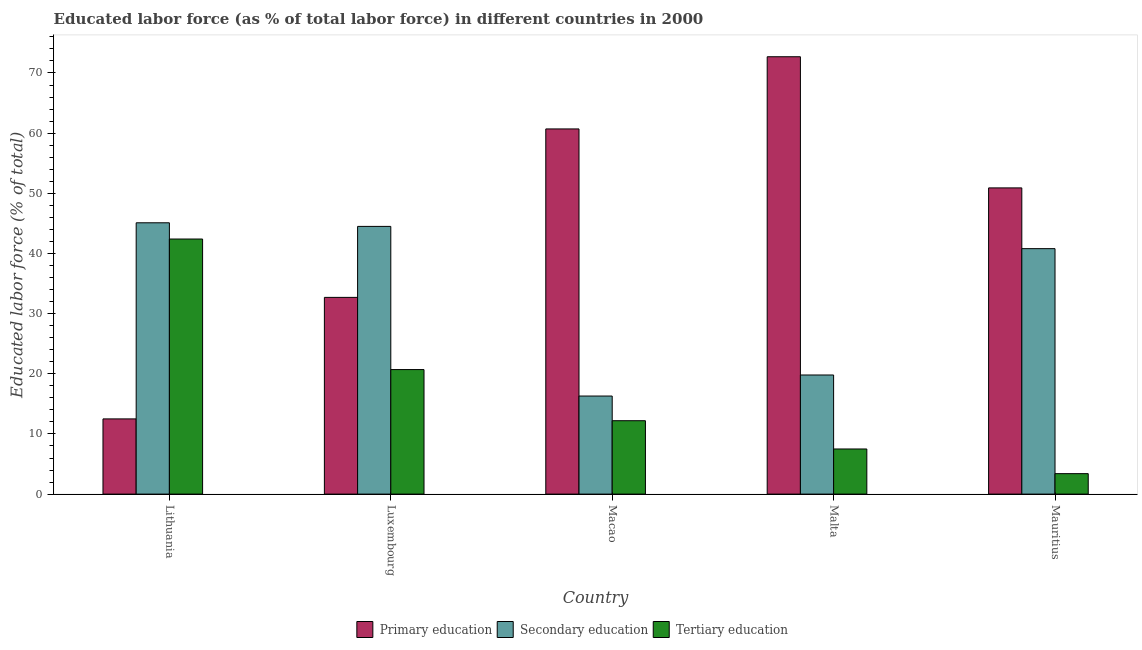How many different coloured bars are there?
Offer a terse response. 3. How many bars are there on the 5th tick from the left?
Provide a succinct answer. 3. What is the label of the 3rd group of bars from the left?
Your response must be concise. Macao. In how many cases, is the number of bars for a given country not equal to the number of legend labels?
Provide a succinct answer. 0. What is the percentage of labor force who received tertiary education in Luxembourg?
Your response must be concise. 20.7. Across all countries, what is the maximum percentage of labor force who received primary education?
Your answer should be compact. 72.7. Across all countries, what is the minimum percentage of labor force who received tertiary education?
Your answer should be compact. 3.4. In which country was the percentage of labor force who received secondary education maximum?
Offer a terse response. Lithuania. In which country was the percentage of labor force who received primary education minimum?
Keep it short and to the point. Lithuania. What is the total percentage of labor force who received tertiary education in the graph?
Provide a short and direct response. 86.2. What is the difference between the percentage of labor force who received tertiary education in Malta and that in Mauritius?
Give a very brief answer. 4.1. What is the difference between the percentage of labor force who received secondary education in Macao and the percentage of labor force who received primary education in Mauritius?
Give a very brief answer. -34.6. What is the average percentage of labor force who received primary education per country?
Ensure brevity in your answer.  45.9. What is the difference between the percentage of labor force who received secondary education and percentage of labor force who received tertiary education in Mauritius?
Provide a short and direct response. 37.4. In how many countries, is the percentage of labor force who received secondary education greater than 72 %?
Your answer should be compact. 0. What is the ratio of the percentage of labor force who received secondary education in Lithuania to that in Malta?
Provide a short and direct response. 2.28. Is the percentage of labor force who received primary education in Luxembourg less than that in Mauritius?
Your response must be concise. Yes. Is the difference between the percentage of labor force who received secondary education in Macao and Mauritius greater than the difference between the percentage of labor force who received tertiary education in Macao and Mauritius?
Provide a short and direct response. No. What is the difference between the highest and the second highest percentage of labor force who received tertiary education?
Provide a succinct answer. 21.7. What is the difference between the highest and the lowest percentage of labor force who received secondary education?
Make the answer very short. 28.8. In how many countries, is the percentage of labor force who received primary education greater than the average percentage of labor force who received primary education taken over all countries?
Provide a succinct answer. 3. What does the 1st bar from the left in Lithuania represents?
Keep it short and to the point. Primary education. How many bars are there?
Offer a terse response. 15. How many countries are there in the graph?
Your answer should be very brief. 5. What is the difference between two consecutive major ticks on the Y-axis?
Offer a terse response. 10. Are the values on the major ticks of Y-axis written in scientific E-notation?
Offer a terse response. No. Where does the legend appear in the graph?
Your answer should be very brief. Bottom center. How many legend labels are there?
Your answer should be very brief. 3. What is the title of the graph?
Offer a very short reply. Educated labor force (as % of total labor force) in different countries in 2000. Does "Coal" appear as one of the legend labels in the graph?
Offer a terse response. No. What is the label or title of the Y-axis?
Make the answer very short. Educated labor force (% of total). What is the Educated labor force (% of total) of Secondary education in Lithuania?
Provide a succinct answer. 45.1. What is the Educated labor force (% of total) of Tertiary education in Lithuania?
Your answer should be very brief. 42.4. What is the Educated labor force (% of total) in Primary education in Luxembourg?
Keep it short and to the point. 32.7. What is the Educated labor force (% of total) in Secondary education in Luxembourg?
Give a very brief answer. 44.5. What is the Educated labor force (% of total) in Tertiary education in Luxembourg?
Offer a very short reply. 20.7. What is the Educated labor force (% of total) in Primary education in Macao?
Your answer should be very brief. 60.7. What is the Educated labor force (% of total) of Secondary education in Macao?
Give a very brief answer. 16.3. What is the Educated labor force (% of total) in Tertiary education in Macao?
Make the answer very short. 12.2. What is the Educated labor force (% of total) in Primary education in Malta?
Make the answer very short. 72.7. What is the Educated labor force (% of total) in Secondary education in Malta?
Make the answer very short. 19.8. What is the Educated labor force (% of total) of Tertiary education in Malta?
Your answer should be very brief. 7.5. What is the Educated labor force (% of total) in Primary education in Mauritius?
Give a very brief answer. 50.9. What is the Educated labor force (% of total) of Secondary education in Mauritius?
Your answer should be very brief. 40.8. What is the Educated labor force (% of total) in Tertiary education in Mauritius?
Your response must be concise. 3.4. Across all countries, what is the maximum Educated labor force (% of total) in Primary education?
Offer a very short reply. 72.7. Across all countries, what is the maximum Educated labor force (% of total) of Secondary education?
Give a very brief answer. 45.1. Across all countries, what is the maximum Educated labor force (% of total) in Tertiary education?
Provide a succinct answer. 42.4. Across all countries, what is the minimum Educated labor force (% of total) in Primary education?
Ensure brevity in your answer.  12.5. Across all countries, what is the minimum Educated labor force (% of total) of Secondary education?
Provide a succinct answer. 16.3. Across all countries, what is the minimum Educated labor force (% of total) in Tertiary education?
Offer a very short reply. 3.4. What is the total Educated labor force (% of total) of Primary education in the graph?
Give a very brief answer. 229.5. What is the total Educated labor force (% of total) of Secondary education in the graph?
Offer a very short reply. 166.5. What is the total Educated labor force (% of total) of Tertiary education in the graph?
Offer a very short reply. 86.2. What is the difference between the Educated labor force (% of total) in Primary education in Lithuania and that in Luxembourg?
Keep it short and to the point. -20.2. What is the difference between the Educated labor force (% of total) of Secondary education in Lithuania and that in Luxembourg?
Keep it short and to the point. 0.6. What is the difference between the Educated labor force (% of total) in Tertiary education in Lithuania and that in Luxembourg?
Offer a very short reply. 21.7. What is the difference between the Educated labor force (% of total) in Primary education in Lithuania and that in Macao?
Offer a terse response. -48.2. What is the difference between the Educated labor force (% of total) in Secondary education in Lithuania and that in Macao?
Make the answer very short. 28.8. What is the difference between the Educated labor force (% of total) of Tertiary education in Lithuania and that in Macao?
Your response must be concise. 30.2. What is the difference between the Educated labor force (% of total) of Primary education in Lithuania and that in Malta?
Provide a succinct answer. -60.2. What is the difference between the Educated labor force (% of total) in Secondary education in Lithuania and that in Malta?
Provide a succinct answer. 25.3. What is the difference between the Educated labor force (% of total) of Tertiary education in Lithuania and that in Malta?
Your answer should be very brief. 34.9. What is the difference between the Educated labor force (% of total) in Primary education in Lithuania and that in Mauritius?
Make the answer very short. -38.4. What is the difference between the Educated labor force (% of total) in Secondary education in Lithuania and that in Mauritius?
Provide a succinct answer. 4.3. What is the difference between the Educated labor force (% of total) of Secondary education in Luxembourg and that in Macao?
Ensure brevity in your answer.  28.2. What is the difference between the Educated labor force (% of total) in Primary education in Luxembourg and that in Malta?
Ensure brevity in your answer.  -40. What is the difference between the Educated labor force (% of total) of Secondary education in Luxembourg and that in Malta?
Your answer should be very brief. 24.7. What is the difference between the Educated labor force (% of total) of Tertiary education in Luxembourg and that in Malta?
Ensure brevity in your answer.  13.2. What is the difference between the Educated labor force (% of total) in Primary education in Luxembourg and that in Mauritius?
Your answer should be very brief. -18.2. What is the difference between the Educated labor force (% of total) in Secondary education in Luxembourg and that in Mauritius?
Ensure brevity in your answer.  3.7. What is the difference between the Educated labor force (% of total) in Tertiary education in Luxembourg and that in Mauritius?
Your answer should be compact. 17.3. What is the difference between the Educated labor force (% of total) of Primary education in Macao and that in Malta?
Your answer should be compact. -12. What is the difference between the Educated labor force (% of total) in Secondary education in Macao and that in Malta?
Offer a terse response. -3.5. What is the difference between the Educated labor force (% of total) of Tertiary education in Macao and that in Malta?
Give a very brief answer. 4.7. What is the difference between the Educated labor force (% of total) in Secondary education in Macao and that in Mauritius?
Make the answer very short. -24.5. What is the difference between the Educated labor force (% of total) in Tertiary education in Macao and that in Mauritius?
Ensure brevity in your answer.  8.8. What is the difference between the Educated labor force (% of total) of Primary education in Malta and that in Mauritius?
Keep it short and to the point. 21.8. What is the difference between the Educated labor force (% of total) of Secondary education in Malta and that in Mauritius?
Provide a succinct answer. -21. What is the difference between the Educated labor force (% of total) of Primary education in Lithuania and the Educated labor force (% of total) of Secondary education in Luxembourg?
Provide a short and direct response. -32. What is the difference between the Educated labor force (% of total) of Secondary education in Lithuania and the Educated labor force (% of total) of Tertiary education in Luxembourg?
Provide a short and direct response. 24.4. What is the difference between the Educated labor force (% of total) in Primary education in Lithuania and the Educated labor force (% of total) in Secondary education in Macao?
Keep it short and to the point. -3.8. What is the difference between the Educated labor force (% of total) in Secondary education in Lithuania and the Educated labor force (% of total) in Tertiary education in Macao?
Keep it short and to the point. 32.9. What is the difference between the Educated labor force (% of total) in Secondary education in Lithuania and the Educated labor force (% of total) in Tertiary education in Malta?
Offer a very short reply. 37.6. What is the difference between the Educated labor force (% of total) of Primary education in Lithuania and the Educated labor force (% of total) of Secondary education in Mauritius?
Offer a very short reply. -28.3. What is the difference between the Educated labor force (% of total) of Secondary education in Lithuania and the Educated labor force (% of total) of Tertiary education in Mauritius?
Give a very brief answer. 41.7. What is the difference between the Educated labor force (% of total) in Primary education in Luxembourg and the Educated labor force (% of total) in Tertiary education in Macao?
Provide a short and direct response. 20.5. What is the difference between the Educated labor force (% of total) of Secondary education in Luxembourg and the Educated labor force (% of total) of Tertiary education in Macao?
Offer a terse response. 32.3. What is the difference between the Educated labor force (% of total) in Primary education in Luxembourg and the Educated labor force (% of total) in Secondary education in Malta?
Keep it short and to the point. 12.9. What is the difference between the Educated labor force (% of total) of Primary education in Luxembourg and the Educated labor force (% of total) of Tertiary education in Malta?
Your answer should be compact. 25.2. What is the difference between the Educated labor force (% of total) of Secondary education in Luxembourg and the Educated labor force (% of total) of Tertiary education in Malta?
Provide a short and direct response. 37. What is the difference between the Educated labor force (% of total) of Primary education in Luxembourg and the Educated labor force (% of total) of Secondary education in Mauritius?
Provide a succinct answer. -8.1. What is the difference between the Educated labor force (% of total) in Primary education in Luxembourg and the Educated labor force (% of total) in Tertiary education in Mauritius?
Give a very brief answer. 29.3. What is the difference between the Educated labor force (% of total) in Secondary education in Luxembourg and the Educated labor force (% of total) in Tertiary education in Mauritius?
Provide a succinct answer. 41.1. What is the difference between the Educated labor force (% of total) of Primary education in Macao and the Educated labor force (% of total) of Secondary education in Malta?
Your response must be concise. 40.9. What is the difference between the Educated labor force (% of total) in Primary education in Macao and the Educated labor force (% of total) in Tertiary education in Malta?
Offer a very short reply. 53.2. What is the difference between the Educated labor force (% of total) in Secondary education in Macao and the Educated labor force (% of total) in Tertiary education in Malta?
Provide a succinct answer. 8.8. What is the difference between the Educated labor force (% of total) in Primary education in Macao and the Educated labor force (% of total) in Tertiary education in Mauritius?
Make the answer very short. 57.3. What is the difference between the Educated labor force (% of total) of Secondary education in Macao and the Educated labor force (% of total) of Tertiary education in Mauritius?
Give a very brief answer. 12.9. What is the difference between the Educated labor force (% of total) in Primary education in Malta and the Educated labor force (% of total) in Secondary education in Mauritius?
Make the answer very short. 31.9. What is the difference between the Educated labor force (% of total) of Primary education in Malta and the Educated labor force (% of total) of Tertiary education in Mauritius?
Offer a very short reply. 69.3. What is the difference between the Educated labor force (% of total) of Secondary education in Malta and the Educated labor force (% of total) of Tertiary education in Mauritius?
Your answer should be compact. 16.4. What is the average Educated labor force (% of total) of Primary education per country?
Ensure brevity in your answer.  45.9. What is the average Educated labor force (% of total) in Secondary education per country?
Your answer should be compact. 33.3. What is the average Educated labor force (% of total) in Tertiary education per country?
Your response must be concise. 17.24. What is the difference between the Educated labor force (% of total) in Primary education and Educated labor force (% of total) in Secondary education in Lithuania?
Offer a very short reply. -32.6. What is the difference between the Educated labor force (% of total) in Primary education and Educated labor force (% of total) in Tertiary education in Lithuania?
Ensure brevity in your answer.  -29.9. What is the difference between the Educated labor force (% of total) in Secondary education and Educated labor force (% of total) in Tertiary education in Luxembourg?
Your response must be concise. 23.8. What is the difference between the Educated labor force (% of total) of Primary education and Educated labor force (% of total) of Secondary education in Macao?
Ensure brevity in your answer.  44.4. What is the difference between the Educated labor force (% of total) in Primary education and Educated labor force (% of total) in Tertiary education in Macao?
Offer a very short reply. 48.5. What is the difference between the Educated labor force (% of total) of Primary education and Educated labor force (% of total) of Secondary education in Malta?
Give a very brief answer. 52.9. What is the difference between the Educated labor force (% of total) of Primary education and Educated labor force (% of total) of Tertiary education in Malta?
Your answer should be very brief. 65.2. What is the difference between the Educated labor force (% of total) of Secondary education and Educated labor force (% of total) of Tertiary education in Malta?
Offer a terse response. 12.3. What is the difference between the Educated labor force (% of total) of Primary education and Educated labor force (% of total) of Tertiary education in Mauritius?
Offer a terse response. 47.5. What is the difference between the Educated labor force (% of total) of Secondary education and Educated labor force (% of total) of Tertiary education in Mauritius?
Keep it short and to the point. 37.4. What is the ratio of the Educated labor force (% of total) of Primary education in Lithuania to that in Luxembourg?
Offer a terse response. 0.38. What is the ratio of the Educated labor force (% of total) of Secondary education in Lithuania to that in Luxembourg?
Provide a short and direct response. 1.01. What is the ratio of the Educated labor force (% of total) in Tertiary education in Lithuania to that in Luxembourg?
Your answer should be very brief. 2.05. What is the ratio of the Educated labor force (% of total) in Primary education in Lithuania to that in Macao?
Your response must be concise. 0.21. What is the ratio of the Educated labor force (% of total) in Secondary education in Lithuania to that in Macao?
Offer a terse response. 2.77. What is the ratio of the Educated labor force (% of total) of Tertiary education in Lithuania to that in Macao?
Offer a very short reply. 3.48. What is the ratio of the Educated labor force (% of total) of Primary education in Lithuania to that in Malta?
Provide a short and direct response. 0.17. What is the ratio of the Educated labor force (% of total) in Secondary education in Lithuania to that in Malta?
Offer a terse response. 2.28. What is the ratio of the Educated labor force (% of total) of Tertiary education in Lithuania to that in Malta?
Make the answer very short. 5.65. What is the ratio of the Educated labor force (% of total) in Primary education in Lithuania to that in Mauritius?
Your answer should be compact. 0.25. What is the ratio of the Educated labor force (% of total) in Secondary education in Lithuania to that in Mauritius?
Your response must be concise. 1.11. What is the ratio of the Educated labor force (% of total) of Tertiary education in Lithuania to that in Mauritius?
Keep it short and to the point. 12.47. What is the ratio of the Educated labor force (% of total) of Primary education in Luxembourg to that in Macao?
Give a very brief answer. 0.54. What is the ratio of the Educated labor force (% of total) in Secondary education in Luxembourg to that in Macao?
Make the answer very short. 2.73. What is the ratio of the Educated labor force (% of total) of Tertiary education in Luxembourg to that in Macao?
Give a very brief answer. 1.7. What is the ratio of the Educated labor force (% of total) in Primary education in Luxembourg to that in Malta?
Your answer should be very brief. 0.45. What is the ratio of the Educated labor force (% of total) in Secondary education in Luxembourg to that in Malta?
Provide a succinct answer. 2.25. What is the ratio of the Educated labor force (% of total) in Tertiary education in Luxembourg to that in Malta?
Ensure brevity in your answer.  2.76. What is the ratio of the Educated labor force (% of total) in Primary education in Luxembourg to that in Mauritius?
Make the answer very short. 0.64. What is the ratio of the Educated labor force (% of total) of Secondary education in Luxembourg to that in Mauritius?
Ensure brevity in your answer.  1.09. What is the ratio of the Educated labor force (% of total) in Tertiary education in Luxembourg to that in Mauritius?
Offer a very short reply. 6.09. What is the ratio of the Educated labor force (% of total) of Primary education in Macao to that in Malta?
Make the answer very short. 0.83. What is the ratio of the Educated labor force (% of total) in Secondary education in Macao to that in Malta?
Keep it short and to the point. 0.82. What is the ratio of the Educated labor force (% of total) in Tertiary education in Macao to that in Malta?
Your answer should be very brief. 1.63. What is the ratio of the Educated labor force (% of total) in Primary education in Macao to that in Mauritius?
Your answer should be very brief. 1.19. What is the ratio of the Educated labor force (% of total) in Secondary education in Macao to that in Mauritius?
Your response must be concise. 0.4. What is the ratio of the Educated labor force (% of total) of Tertiary education in Macao to that in Mauritius?
Your answer should be very brief. 3.59. What is the ratio of the Educated labor force (% of total) in Primary education in Malta to that in Mauritius?
Your response must be concise. 1.43. What is the ratio of the Educated labor force (% of total) of Secondary education in Malta to that in Mauritius?
Provide a short and direct response. 0.49. What is the ratio of the Educated labor force (% of total) in Tertiary education in Malta to that in Mauritius?
Offer a very short reply. 2.21. What is the difference between the highest and the second highest Educated labor force (% of total) in Tertiary education?
Offer a very short reply. 21.7. What is the difference between the highest and the lowest Educated labor force (% of total) of Primary education?
Provide a succinct answer. 60.2. What is the difference between the highest and the lowest Educated labor force (% of total) of Secondary education?
Give a very brief answer. 28.8. 